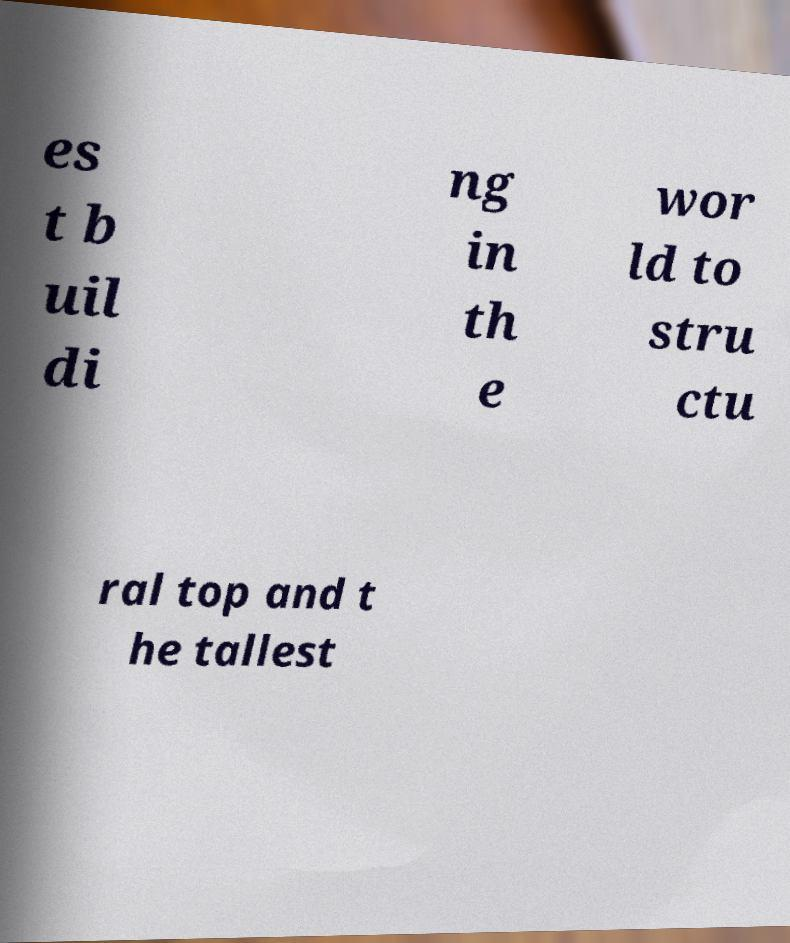For documentation purposes, I need the text within this image transcribed. Could you provide that? es t b uil di ng in th e wor ld to stru ctu ral top and t he tallest 